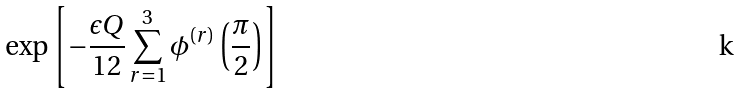<formula> <loc_0><loc_0><loc_500><loc_500>\exp \left [ - \frac { \epsilon Q } { 1 2 } \sum _ { r = 1 } ^ { 3 } \phi ^ { ( r ) } \left ( \frac { \pi } { 2 } \right ) \right ]</formula> 